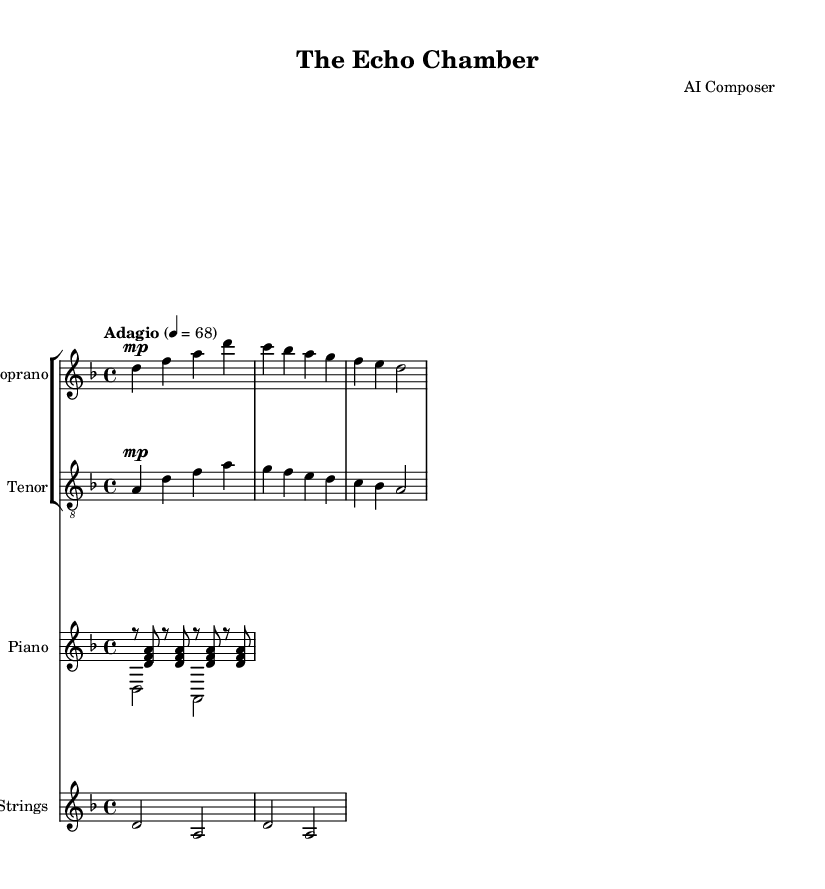What is the key signature of this music? The key signature indicates D minor, which includes one flat (B flat). This is identifiable from the initial part of the score where the key signature is stated before the first note.
Answer: D minor What is the time signature of this sheet music? The time signature is 4/4, which is indicated at the beginning of the score. This means there are four beats per measure, and each beat is a quarter note.
Answer: 4/4 What is the indicated tempo marking for this piece? The tempo marking is "Adagio" and specifies a beat of 68 BPM (beats per minute). This is highlighted in the initial part of the score under the tempo instruction.
Answer: Adagio Which instruments are featured in this piece? The instruments include soprano, tenor, piano, and violin. This is identified in the score where each instrument is labeled at the start of its respective staff.
Answer: Soprano, tenor, piano, violin How many measures does the soprano part contain? The soprano part contains three measures, as indicated by the notation grouped visually within the bracketed staff.
Answer: Three measures What thematic issue is presented in the lyrics? The thematic issue revolves around digital age challenges and the impact on social empathy, as depicted in the lyrics. This can be grasped by reading the lines closely for context.
Answer: Digital age challenges What is the overall mood conveyed by the piece? The overall mood is contemplative and somber, suggested by the key of D minor, the slow tempo, and the lyrical content focused on introspection and social issues. This can be inferred by analyzing the musical elements and the lyrics collectively.
Answer: Contemplative 